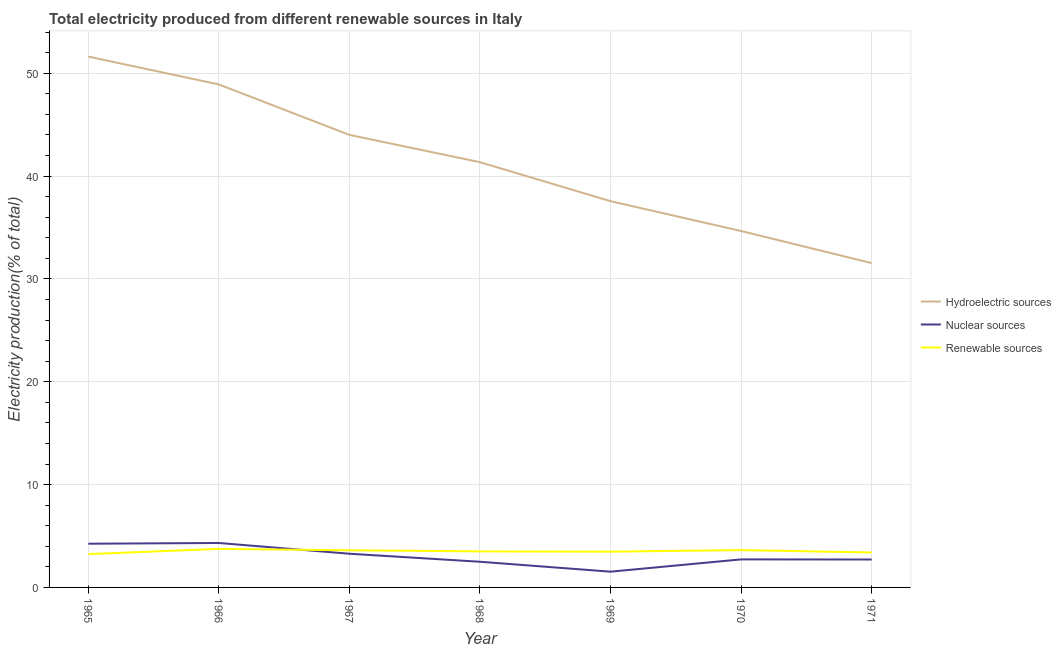How many different coloured lines are there?
Your answer should be very brief. 3. What is the percentage of electricity produced by nuclear sources in 1967?
Your answer should be very brief. 3.28. Across all years, what is the maximum percentage of electricity produced by hydroelectric sources?
Provide a short and direct response. 51.62. Across all years, what is the minimum percentage of electricity produced by nuclear sources?
Provide a succinct answer. 1.53. In which year was the percentage of electricity produced by renewable sources maximum?
Give a very brief answer. 1966. What is the total percentage of electricity produced by nuclear sources in the graph?
Your answer should be compact. 21.32. What is the difference between the percentage of electricity produced by renewable sources in 1965 and that in 1969?
Provide a short and direct response. -0.24. What is the difference between the percentage of electricity produced by hydroelectric sources in 1967 and the percentage of electricity produced by nuclear sources in 1966?
Give a very brief answer. 39.68. What is the average percentage of electricity produced by nuclear sources per year?
Make the answer very short. 3.05. In the year 1968, what is the difference between the percentage of electricity produced by renewable sources and percentage of electricity produced by nuclear sources?
Give a very brief answer. 1.01. In how many years, is the percentage of electricity produced by renewable sources greater than 4 %?
Offer a terse response. 0. What is the ratio of the percentage of electricity produced by nuclear sources in 1968 to that in 1971?
Your answer should be compact. 0.92. Is the percentage of electricity produced by nuclear sources in 1966 less than that in 1968?
Your response must be concise. No. Is the difference between the percentage of electricity produced by renewable sources in 1966 and 1971 greater than the difference between the percentage of electricity produced by hydroelectric sources in 1966 and 1971?
Give a very brief answer. No. What is the difference between the highest and the second highest percentage of electricity produced by nuclear sources?
Offer a terse response. 0.07. What is the difference between the highest and the lowest percentage of electricity produced by hydroelectric sources?
Offer a very short reply. 20.08. Is the sum of the percentage of electricity produced by renewable sources in 1966 and 1968 greater than the maximum percentage of electricity produced by hydroelectric sources across all years?
Your response must be concise. No. Is it the case that in every year, the sum of the percentage of electricity produced by hydroelectric sources and percentage of electricity produced by nuclear sources is greater than the percentage of electricity produced by renewable sources?
Your response must be concise. Yes. Does the percentage of electricity produced by nuclear sources monotonically increase over the years?
Your answer should be very brief. No. Is the percentage of electricity produced by nuclear sources strictly greater than the percentage of electricity produced by hydroelectric sources over the years?
Your answer should be very brief. No. How many lines are there?
Make the answer very short. 3. Does the graph contain any zero values?
Provide a short and direct response. No. How are the legend labels stacked?
Offer a very short reply. Vertical. What is the title of the graph?
Provide a succinct answer. Total electricity produced from different renewable sources in Italy. What is the label or title of the X-axis?
Ensure brevity in your answer.  Year. What is the label or title of the Y-axis?
Keep it short and to the point. Electricity production(% of total). What is the Electricity production(% of total) in Hydroelectric sources in 1965?
Your response must be concise. 51.62. What is the Electricity production(% of total) of Nuclear sources in 1965?
Your answer should be compact. 4.25. What is the Electricity production(% of total) in Renewable sources in 1965?
Offer a terse response. 3.24. What is the Electricity production(% of total) in Hydroelectric sources in 1966?
Ensure brevity in your answer.  48.91. What is the Electricity production(% of total) in Nuclear sources in 1966?
Provide a succinct answer. 4.32. What is the Electricity production(% of total) in Renewable sources in 1966?
Your response must be concise. 3.75. What is the Electricity production(% of total) of Hydroelectric sources in 1967?
Ensure brevity in your answer.  44. What is the Electricity production(% of total) in Nuclear sources in 1967?
Offer a very short reply. 3.28. What is the Electricity production(% of total) in Renewable sources in 1967?
Keep it short and to the point. 3.61. What is the Electricity production(% of total) of Hydroelectric sources in 1968?
Make the answer very short. 41.35. What is the Electricity production(% of total) in Nuclear sources in 1968?
Provide a succinct answer. 2.5. What is the Electricity production(% of total) of Renewable sources in 1968?
Keep it short and to the point. 3.5. What is the Electricity production(% of total) of Hydroelectric sources in 1969?
Your answer should be compact. 37.56. What is the Electricity production(% of total) in Nuclear sources in 1969?
Your answer should be very brief. 1.53. What is the Electricity production(% of total) in Renewable sources in 1969?
Make the answer very short. 3.48. What is the Electricity production(% of total) of Hydroelectric sources in 1970?
Your response must be concise. 34.66. What is the Electricity production(% of total) of Nuclear sources in 1970?
Ensure brevity in your answer.  2.73. What is the Electricity production(% of total) in Renewable sources in 1970?
Your response must be concise. 3.63. What is the Electricity production(% of total) of Hydroelectric sources in 1971?
Make the answer very short. 31.54. What is the Electricity production(% of total) of Nuclear sources in 1971?
Ensure brevity in your answer.  2.72. What is the Electricity production(% of total) in Renewable sources in 1971?
Provide a short and direct response. 3.4. Across all years, what is the maximum Electricity production(% of total) in Hydroelectric sources?
Make the answer very short. 51.62. Across all years, what is the maximum Electricity production(% of total) in Nuclear sources?
Give a very brief answer. 4.32. Across all years, what is the maximum Electricity production(% of total) of Renewable sources?
Make the answer very short. 3.75. Across all years, what is the minimum Electricity production(% of total) in Hydroelectric sources?
Your response must be concise. 31.54. Across all years, what is the minimum Electricity production(% of total) of Nuclear sources?
Your answer should be compact. 1.53. Across all years, what is the minimum Electricity production(% of total) of Renewable sources?
Provide a succinct answer. 3.24. What is the total Electricity production(% of total) in Hydroelectric sources in the graph?
Give a very brief answer. 289.63. What is the total Electricity production(% of total) in Nuclear sources in the graph?
Keep it short and to the point. 21.32. What is the total Electricity production(% of total) of Renewable sources in the graph?
Offer a terse response. 24.61. What is the difference between the Electricity production(% of total) in Hydroelectric sources in 1965 and that in 1966?
Your response must be concise. 2.71. What is the difference between the Electricity production(% of total) of Nuclear sources in 1965 and that in 1966?
Provide a succinct answer. -0.07. What is the difference between the Electricity production(% of total) of Renewable sources in 1965 and that in 1966?
Offer a terse response. -0.51. What is the difference between the Electricity production(% of total) of Hydroelectric sources in 1965 and that in 1967?
Your answer should be compact. 7.62. What is the difference between the Electricity production(% of total) in Nuclear sources in 1965 and that in 1967?
Provide a short and direct response. 0.97. What is the difference between the Electricity production(% of total) in Renewable sources in 1965 and that in 1967?
Your response must be concise. -0.37. What is the difference between the Electricity production(% of total) of Hydroelectric sources in 1965 and that in 1968?
Your answer should be very brief. 10.27. What is the difference between the Electricity production(% of total) in Nuclear sources in 1965 and that in 1968?
Give a very brief answer. 1.75. What is the difference between the Electricity production(% of total) of Renewable sources in 1965 and that in 1968?
Your response must be concise. -0.26. What is the difference between the Electricity production(% of total) in Hydroelectric sources in 1965 and that in 1969?
Make the answer very short. 14.06. What is the difference between the Electricity production(% of total) in Nuclear sources in 1965 and that in 1969?
Provide a short and direct response. 2.72. What is the difference between the Electricity production(% of total) in Renewable sources in 1965 and that in 1969?
Give a very brief answer. -0.24. What is the difference between the Electricity production(% of total) in Hydroelectric sources in 1965 and that in 1970?
Your answer should be very brief. 16.96. What is the difference between the Electricity production(% of total) of Nuclear sources in 1965 and that in 1970?
Offer a terse response. 1.52. What is the difference between the Electricity production(% of total) in Renewable sources in 1965 and that in 1970?
Offer a very short reply. -0.39. What is the difference between the Electricity production(% of total) in Hydroelectric sources in 1965 and that in 1971?
Provide a short and direct response. 20.08. What is the difference between the Electricity production(% of total) of Nuclear sources in 1965 and that in 1971?
Provide a succinct answer. 1.53. What is the difference between the Electricity production(% of total) of Renewable sources in 1965 and that in 1971?
Your response must be concise. -0.16. What is the difference between the Electricity production(% of total) of Hydroelectric sources in 1966 and that in 1967?
Your answer should be compact. 4.9. What is the difference between the Electricity production(% of total) in Nuclear sources in 1966 and that in 1967?
Your answer should be compact. 1.05. What is the difference between the Electricity production(% of total) in Renewable sources in 1966 and that in 1967?
Provide a succinct answer. 0.14. What is the difference between the Electricity production(% of total) in Hydroelectric sources in 1966 and that in 1968?
Provide a short and direct response. 7.56. What is the difference between the Electricity production(% of total) in Nuclear sources in 1966 and that in 1968?
Make the answer very short. 1.83. What is the difference between the Electricity production(% of total) of Renewable sources in 1966 and that in 1968?
Ensure brevity in your answer.  0.24. What is the difference between the Electricity production(% of total) of Hydroelectric sources in 1966 and that in 1969?
Provide a short and direct response. 11.35. What is the difference between the Electricity production(% of total) in Nuclear sources in 1966 and that in 1969?
Your response must be concise. 2.79. What is the difference between the Electricity production(% of total) of Renewable sources in 1966 and that in 1969?
Offer a very short reply. 0.27. What is the difference between the Electricity production(% of total) of Hydroelectric sources in 1966 and that in 1970?
Provide a succinct answer. 14.25. What is the difference between the Electricity production(% of total) in Nuclear sources in 1966 and that in 1970?
Ensure brevity in your answer.  1.6. What is the difference between the Electricity production(% of total) of Renewable sources in 1966 and that in 1970?
Offer a very short reply. 0.12. What is the difference between the Electricity production(% of total) of Hydroelectric sources in 1966 and that in 1971?
Your answer should be compact. 17.37. What is the difference between the Electricity production(% of total) in Nuclear sources in 1966 and that in 1971?
Ensure brevity in your answer.  1.61. What is the difference between the Electricity production(% of total) of Renewable sources in 1966 and that in 1971?
Your response must be concise. 0.35. What is the difference between the Electricity production(% of total) of Hydroelectric sources in 1967 and that in 1968?
Provide a succinct answer. 2.65. What is the difference between the Electricity production(% of total) in Nuclear sources in 1967 and that in 1968?
Make the answer very short. 0.78. What is the difference between the Electricity production(% of total) in Renewable sources in 1967 and that in 1968?
Keep it short and to the point. 0.11. What is the difference between the Electricity production(% of total) in Hydroelectric sources in 1967 and that in 1969?
Make the answer very short. 6.45. What is the difference between the Electricity production(% of total) in Nuclear sources in 1967 and that in 1969?
Your response must be concise. 1.74. What is the difference between the Electricity production(% of total) in Renewable sources in 1967 and that in 1969?
Your answer should be very brief. 0.13. What is the difference between the Electricity production(% of total) of Hydroelectric sources in 1967 and that in 1970?
Offer a terse response. 9.35. What is the difference between the Electricity production(% of total) of Nuclear sources in 1967 and that in 1970?
Keep it short and to the point. 0.55. What is the difference between the Electricity production(% of total) of Renewable sources in 1967 and that in 1970?
Ensure brevity in your answer.  -0.02. What is the difference between the Electricity production(% of total) of Hydroelectric sources in 1967 and that in 1971?
Provide a succinct answer. 12.47. What is the difference between the Electricity production(% of total) of Nuclear sources in 1967 and that in 1971?
Keep it short and to the point. 0.56. What is the difference between the Electricity production(% of total) in Renewable sources in 1967 and that in 1971?
Provide a short and direct response. 0.21. What is the difference between the Electricity production(% of total) of Hydroelectric sources in 1968 and that in 1969?
Offer a terse response. 3.79. What is the difference between the Electricity production(% of total) of Nuclear sources in 1968 and that in 1969?
Make the answer very short. 0.96. What is the difference between the Electricity production(% of total) of Renewable sources in 1968 and that in 1969?
Offer a terse response. 0.03. What is the difference between the Electricity production(% of total) in Hydroelectric sources in 1968 and that in 1970?
Ensure brevity in your answer.  6.69. What is the difference between the Electricity production(% of total) in Nuclear sources in 1968 and that in 1970?
Offer a very short reply. -0.23. What is the difference between the Electricity production(% of total) of Renewable sources in 1968 and that in 1970?
Your response must be concise. -0.12. What is the difference between the Electricity production(% of total) in Hydroelectric sources in 1968 and that in 1971?
Provide a short and direct response. 9.81. What is the difference between the Electricity production(% of total) in Nuclear sources in 1968 and that in 1971?
Offer a terse response. -0.22. What is the difference between the Electricity production(% of total) of Renewable sources in 1968 and that in 1971?
Your answer should be compact. 0.11. What is the difference between the Electricity production(% of total) in Nuclear sources in 1969 and that in 1970?
Ensure brevity in your answer.  -1.19. What is the difference between the Electricity production(% of total) of Renewable sources in 1969 and that in 1970?
Keep it short and to the point. -0.15. What is the difference between the Electricity production(% of total) of Hydroelectric sources in 1969 and that in 1971?
Provide a succinct answer. 6.02. What is the difference between the Electricity production(% of total) in Nuclear sources in 1969 and that in 1971?
Offer a very short reply. -1.18. What is the difference between the Electricity production(% of total) of Renewable sources in 1969 and that in 1971?
Offer a terse response. 0.08. What is the difference between the Electricity production(% of total) in Hydroelectric sources in 1970 and that in 1971?
Provide a succinct answer. 3.12. What is the difference between the Electricity production(% of total) of Nuclear sources in 1970 and that in 1971?
Keep it short and to the point. 0.01. What is the difference between the Electricity production(% of total) of Renewable sources in 1970 and that in 1971?
Provide a succinct answer. 0.23. What is the difference between the Electricity production(% of total) of Hydroelectric sources in 1965 and the Electricity production(% of total) of Nuclear sources in 1966?
Give a very brief answer. 47.3. What is the difference between the Electricity production(% of total) in Hydroelectric sources in 1965 and the Electricity production(% of total) in Renewable sources in 1966?
Your answer should be very brief. 47.87. What is the difference between the Electricity production(% of total) in Nuclear sources in 1965 and the Electricity production(% of total) in Renewable sources in 1966?
Offer a very short reply. 0.5. What is the difference between the Electricity production(% of total) of Hydroelectric sources in 1965 and the Electricity production(% of total) of Nuclear sources in 1967?
Provide a short and direct response. 48.34. What is the difference between the Electricity production(% of total) of Hydroelectric sources in 1965 and the Electricity production(% of total) of Renewable sources in 1967?
Keep it short and to the point. 48.01. What is the difference between the Electricity production(% of total) in Nuclear sources in 1965 and the Electricity production(% of total) in Renewable sources in 1967?
Make the answer very short. 0.64. What is the difference between the Electricity production(% of total) in Hydroelectric sources in 1965 and the Electricity production(% of total) in Nuclear sources in 1968?
Give a very brief answer. 49.12. What is the difference between the Electricity production(% of total) in Hydroelectric sources in 1965 and the Electricity production(% of total) in Renewable sources in 1968?
Offer a terse response. 48.11. What is the difference between the Electricity production(% of total) in Nuclear sources in 1965 and the Electricity production(% of total) in Renewable sources in 1968?
Give a very brief answer. 0.75. What is the difference between the Electricity production(% of total) of Hydroelectric sources in 1965 and the Electricity production(% of total) of Nuclear sources in 1969?
Make the answer very short. 50.09. What is the difference between the Electricity production(% of total) of Hydroelectric sources in 1965 and the Electricity production(% of total) of Renewable sources in 1969?
Your response must be concise. 48.14. What is the difference between the Electricity production(% of total) of Nuclear sources in 1965 and the Electricity production(% of total) of Renewable sources in 1969?
Keep it short and to the point. 0.77. What is the difference between the Electricity production(% of total) in Hydroelectric sources in 1965 and the Electricity production(% of total) in Nuclear sources in 1970?
Offer a terse response. 48.89. What is the difference between the Electricity production(% of total) of Hydroelectric sources in 1965 and the Electricity production(% of total) of Renewable sources in 1970?
Keep it short and to the point. 47.99. What is the difference between the Electricity production(% of total) in Nuclear sources in 1965 and the Electricity production(% of total) in Renewable sources in 1970?
Provide a succinct answer. 0.62. What is the difference between the Electricity production(% of total) in Hydroelectric sources in 1965 and the Electricity production(% of total) in Nuclear sources in 1971?
Keep it short and to the point. 48.9. What is the difference between the Electricity production(% of total) of Hydroelectric sources in 1965 and the Electricity production(% of total) of Renewable sources in 1971?
Keep it short and to the point. 48.22. What is the difference between the Electricity production(% of total) in Nuclear sources in 1965 and the Electricity production(% of total) in Renewable sources in 1971?
Ensure brevity in your answer.  0.85. What is the difference between the Electricity production(% of total) of Hydroelectric sources in 1966 and the Electricity production(% of total) of Nuclear sources in 1967?
Provide a succinct answer. 45.63. What is the difference between the Electricity production(% of total) of Hydroelectric sources in 1966 and the Electricity production(% of total) of Renewable sources in 1967?
Make the answer very short. 45.3. What is the difference between the Electricity production(% of total) of Nuclear sources in 1966 and the Electricity production(% of total) of Renewable sources in 1967?
Offer a terse response. 0.71. What is the difference between the Electricity production(% of total) of Hydroelectric sources in 1966 and the Electricity production(% of total) of Nuclear sources in 1968?
Keep it short and to the point. 46.41. What is the difference between the Electricity production(% of total) of Hydroelectric sources in 1966 and the Electricity production(% of total) of Renewable sources in 1968?
Your answer should be very brief. 45.4. What is the difference between the Electricity production(% of total) in Nuclear sources in 1966 and the Electricity production(% of total) in Renewable sources in 1968?
Ensure brevity in your answer.  0.82. What is the difference between the Electricity production(% of total) in Hydroelectric sources in 1966 and the Electricity production(% of total) in Nuclear sources in 1969?
Give a very brief answer. 47.38. What is the difference between the Electricity production(% of total) in Hydroelectric sources in 1966 and the Electricity production(% of total) in Renewable sources in 1969?
Give a very brief answer. 45.43. What is the difference between the Electricity production(% of total) of Nuclear sources in 1966 and the Electricity production(% of total) of Renewable sources in 1969?
Your response must be concise. 0.84. What is the difference between the Electricity production(% of total) of Hydroelectric sources in 1966 and the Electricity production(% of total) of Nuclear sources in 1970?
Provide a succinct answer. 46.18. What is the difference between the Electricity production(% of total) of Hydroelectric sources in 1966 and the Electricity production(% of total) of Renewable sources in 1970?
Provide a short and direct response. 45.28. What is the difference between the Electricity production(% of total) of Nuclear sources in 1966 and the Electricity production(% of total) of Renewable sources in 1970?
Your response must be concise. 0.69. What is the difference between the Electricity production(% of total) of Hydroelectric sources in 1966 and the Electricity production(% of total) of Nuclear sources in 1971?
Your answer should be compact. 46.19. What is the difference between the Electricity production(% of total) in Hydroelectric sources in 1966 and the Electricity production(% of total) in Renewable sources in 1971?
Your answer should be very brief. 45.51. What is the difference between the Electricity production(% of total) in Nuclear sources in 1966 and the Electricity production(% of total) in Renewable sources in 1971?
Your response must be concise. 0.92. What is the difference between the Electricity production(% of total) in Hydroelectric sources in 1967 and the Electricity production(% of total) in Nuclear sources in 1968?
Offer a terse response. 41.51. What is the difference between the Electricity production(% of total) of Hydroelectric sources in 1967 and the Electricity production(% of total) of Renewable sources in 1968?
Ensure brevity in your answer.  40.5. What is the difference between the Electricity production(% of total) in Nuclear sources in 1967 and the Electricity production(% of total) in Renewable sources in 1968?
Offer a very short reply. -0.23. What is the difference between the Electricity production(% of total) of Hydroelectric sources in 1967 and the Electricity production(% of total) of Nuclear sources in 1969?
Make the answer very short. 42.47. What is the difference between the Electricity production(% of total) of Hydroelectric sources in 1967 and the Electricity production(% of total) of Renewable sources in 1969?
Offer a very short reply. 40.53. What is the difference between the Electricity production(% of total) of Nuclear sources in 1967 and the Electricity production(% of total) of Renewable sources in 1969?
Offer a terse response. -0.2. What is the difference between the Electricity production(% of total) in Hydroelectric sources in 1967 and the Electricity production(% of total) in Nuclear sources in 1970?
Your answer should be very brief. 41.28. What is the difference between the Electricity production(% of total) in Hydroelectric sources in 1967 and the Electricity production(% of total) in Renewable sources in 1970?
Make the answer very short. 40.37. What is the difference between the Electricity production(% of total) of Nuclear sources in 1967 and the Electricity production(% of total) of Renewable sources in 1970?
Keep it short and to the point. -0.35. What is the difference between the Electricity production(% of total) in Hydroelectric sources in 1967 and the Electricity production(% of total) in Nuclear sources in 1971?
Offer a very short reply. 41.29. What is the difference between the Electricity production(% of total) in Hydroelectric sources in 1967 and the Electricity production(% of total) in Renewable sources in 1971?
Provide a succinct answer. 40.61. What is the difference between the Electricity production(% of total) of Nuclear sources in 1967 and the Electricity production(% of total) of Renewable sources in 1971?
Ensure brevity in your answer.  -0.12. What is the difference between the Electricity production(% of total) of Hydroelectric sources in 1968 and the Electricity production(% of total) of Nuclear sources in 1969?
Your answer should be very brief. 39.82. What is the difference between the Electricity production(% of total) of Hydroelectric sources in 1968 and the Electricity production(% of total) of Renewable sources in 1969?
Keep it short and to the point. 37.87. What is the difference between the Electricity production(% of total) in Nuclear sources in 1968 and the Electricity production(% of total) in Renewable sources in 1969?
Offer a terse response. -0.98. What is the difference between the Electricity production(% of total) in Hydroelectric sources in 1968 and the Electricity production(% of total) in Nuclear sources in 1970?
Make the answer very short. 38.62. What is the difference between the Electricity production(% of total) of Hydroelectric sources in 1968 and the Electricity production(% of total) of Renewable sources in 1970?
Ensure brevity in your answer.  37.72. What is the difference between the Electricity production(% of total) in Nuclear sources in 1968 and the Electricity production(% of total) in Renewable sources in 1970?
Provide a short and direct response. -1.13. What is the difference between the Electricity production(% of total) of Hydroelectric sources in 1968 and the Electricity production(% of total) of Nuclear sources in 1971?
Provide a succinct answer. 38.63. What is the difference between the Electricity production(% of total) of Hydroelectric sources in 1968 and the Electricity production(% of total) of Renewable sources in 1971?
Offer a very short reply. 37.95. What is the difference between the Electricity production(% of total) of Nuclear sources in 1968 and the Electricity production(% of total) of Renewable sources in 1971?
Your answer should be compact. -0.9. What is the difference between the Electricity production(% of total) in Hydroelectric sources in 1969 and the Electricity production(% of total) in Nuclear sources in 1970?
Your response must be concise. 34.83. What is the difference between the Electricity production(% of total) in Hydroelectric sources in 1969 and the Electricity production(% of total) in Renewable sources in 1970?
Give a very brief answer. 33.93. What is the difference between the Electricity production(% of total) of Nuclear sources in 1969 and the Electricity production(% of total) of Renewable sources in 1970?
Ensure brevity in your answer.  -2.1. What is the difference between the Electricity production(% of total) of Hydroelectric sources in 1969 and the Electricity production(% of total) of Nuclear sources in 1971?
Ensure brevity in your answer.  34.84. What is the difference between the Electricity production(% of total) in Hydroelectric sources in 1969 and the Electricity production(% of total) in Renewable sources in 1971?
Provide a short and direct response. 34.16. What is the difference between the Electricity production(% of total) of Nuclear sources in 1969 and the Electricity production(% of total) of Renewable sources in 1971?
Give a very brief answer. -1.86. What is the difference between the Electricity production(% of total) in Hydroelectric sources in 1970 and the Electricity production(% of total) in Nuclear sources in 1971?
Offer a very short reply. 31.94. What is the difference between the Electricity production(% of total) in Hydroelectric sources in 1970 and the Electricity production(% of total) in Renewable sources in 1971?
Ensure brevity in your answer.  31.26. What is the difference between the Electricity production(% of total) in Nuclear sources in 1970 and the Electricity production(% of total) in Renewable sources in 1971?
Ensure brevity in your answer.  -0.67. What is the average Electricity production(% of total) in Hydroelectric sources per year?
Keep it short and to the point. 41.38. What is the average Electricity production(% of total) of Nuclear sources per year?
Make the answer very short. 3.05. What is the average Electricity production(% of total) of Renewable sources per year?
Offer a terse response. 3.52. In the year 1965, what is the difference between the Electricity production(% of total) in Hydroelectric sources and Electricity production(% of total) in Nuclear sources?
Offer a very short reply. 47.37. In the year 1965, what is the difference between the Electricity production(% of total) of Hydroelectric sources and Electricity production(% of total) of Renewable sources?
Offer a very short reply. 48.38. In the year 1965, what is the difference between the Electricity production(% of total) in Nuclear sources and Electricity production(% of total) in Renewable sources?
Offer a very short reply. 1.01. In the year 1966, what is the difference between the Electricity production(% of total) of Hydroelectric sources and Electricity production(% of total) of Nuclear sources?
Keep it short and to the point. 44.59. In the year 1966, what is the difference between the Electricity production(% of total) in Hydroelectric sources and Electricity production(% of total) in Renewable sources?
Give a very brief answer. 45.16. In the year 1966, what is the difference between the Electricity production(% of total) in Nuclear sources and Electricity production(% of total) in Renewable sources?
Give a very brief answer. 0.57. In the year 1967, what is the difference between the Electricity production(% of total) in Hydroelectric sources and Electricity production(% of total) in Nuclear sources?
Ensure brevity in your answer.  40.73. In the year 1967, what is the difference between the Electricity production(% of total) of Hydroelectric sources and Electricity production(% of total) of Renewable sources?
Your answer should be very brief. 40.39. In the year 1967, what is the difference between the Electricity production(% of total) of Nuclear sources and Electricity production(% of total) of Renewable sources?
Keep it short and to the point. -0.34. In the year 1968, what is the difference between the Electricity production(% of total) in Hydroelectric sources and Electricity production(% of total) in Nuclear sources?
Your response must be concise. 38.85. In the year 1968, what is the difference between the Electricity production(% of total) in Hydroelectric sources and Electricity production(% of total) in Renewable sources?
Offer a very short reply. 37.84. In the year 1968, what is the difference between the Electricity production(% of total) of Nuclear sources and Electricity production(% of total) of Renewable sources?
Give a very brief answer. -1.01. In the year 1969, what is the difference between the Electricity production(% of total) of Hydroelectric sources and Electricity production(% of total) of Nuclear sources?
Offer a terse response. 36.02. In the year 1969, what is the difference between the Electricity production(% of total) in Hydroelectric sources and Electricity production(% of total) in Renewable sources?
Offer a terse response. 34.08. In the year 1969, what is the difference between the Electricity production(% of total) of Nuclear sources and Electricity production(% of total) of Renewable sources?
Keep it short and to the point. -1.95. In the year 1970, what is the difference between the Electricity production(% of total) in Hydroelectric sources and Electricity production(% of total) in Nuclear sources?
Make the answer very short. 31.93. In the year 1970, what is the difference between the Electricity production(% of total) of Hydroelectric sources and Electricity production(% of total) of Renewable sources?
Your answer should be compact. 31.03. In the year 1970, what is the difference between the Electricity production(% of total) of Nuclear sources and Electricity production(% of total) of Renewable sources?
Your answer should be very brief. -0.9. In the year 1971, what is the difference between the Electricity production(% of total) in Hydroelectric sources and Electricity production(% of total) in Nuclear sources?
Provide a succinct answer. 28.82. In the year 1971, what is the difference between the Electricity production(% of total) of Hydroelectric sources and Electricity production(% of total) of Renewable sources?
Give a very brief answer. 28.14. In the year 1971, what is the difference between the Electricity production(% of total) of Nuclear sources and Electricity production(% of total) of Renewable sources?
Make the answer very short. -0.68. What is the ratio of the Electricity production(% of total) in Hydroelectric sources in 1965 to that in 1966?
Your response must be concise. 1.06. What is the ratio of the Electricity production(% of total) in Nuclear sources in 1965 to that in 1966?
Ensure brevity in your answer.  0.98. What is the ratio of the Electricity production(% of total) of Renewable sources in 1965 to that in 1966?
Provide a succinct answer. 0.86. What is the ratio of the Electricity production(% of total) in Hydroelectric sources in 1965 to that in 1967?
Your answer should be very brief. 1.17. What is the ratio of the Electricity production(% of total) of Nuclear sources in 1965 to that in 1967?
Provide a succinct answer. 1.3. What is the ratio of the Electricity production(% of total) in Renewable sources in 1965 to that in 1967?
Your answer should be compact. 0.9. What is the ratio of the Electricity production(% of total) of Hydroelectric sources in 1965 to that in 1968?
Your response must be concise. 1.25. What is the ratio of the Electricity production(% of total) of Nuclear sources in 1965 to that in 1968?
Keep it short and to the point. 1.7. What is the ratio of the Electricity production(% of total) of Renewable sources in 1965 to that in 1968?
Your answer should be compact. 0.92. What is the ratio of the Electricity production(% of total) of Hydroelectric sources in 1965 to that in 1969?
Provide a short and direct response. 1.37. What is the ratio of the Electricity production(% of total) of Nuclear sources in 1965 to that in 1969?
Keep it short and to the point. 2.77. What is the ratio of the Electricity production(% of total) of Renewable sources in 1965 to that in 1969?
Ensure brevity in your answer.  0.93. What is the ratio of the Electricity production(% of total) in Hydroelectric sources in 1965 to that in 1970?
Your response must be concise. 1.49. What is the ratio of the Electricity production(% of total) of Nuclear sources in 1965 to that in 1970?
Ensure brevity in your answer.  1.56. What is the ratio of the Electricity production(% of total) of Renewable sources in 1965 to that in 1970?
Your answer should be compact. 0.89. What is the ratio of the Electricity production(% of total) of Hydroelectric sources in 1965 to that in 1971?
Make the answer very short. 1.64. What is the ratio of the Electricity production(% of total) of Nuclear sources in 1965 to that in 1971?
Provide a succinct answer. 1.56. What is the ratio of the Electricity production(% of total) in Renewable sources in 1965 to that in 1971?
Offer a terse response. 0.95. What is the ratio of the Electricity production(% of total) of Hydroelectric sources in 1966 to that in 1967?
Your answer should be very brief. 1.11. What is the ratio of the Electricity production(% of total) of Nuclear sources in 1966 to that in 1967?
Make the answer very short. 1.32. What is the ratio of the Electricity production(% of total) in Renewable sources in 1966 to that in 1967?
Offer a very short reply. 1.04. What is the ratio of the Electricity production(% of total) in Hydroelectric sources in 1966 to that in 1968?
Make the answer very short. 1.18. What is the ratio of the Electricity production(% of total) of Nuclear sources in 1966 to that in 1968?
Offer a terse response. 1.73. What is the ratio of the Electricity production(% of total) of Renewable sources in 1966 to that in 1968?
Your answer should be very brief. 1.07. What is the ratio of the Electricity production(% of total) of Hydroelectric sources in 1966 to that in 1969?
Ensure brevity in your answer.  1.3. What is the ratio of the Electricity production(% of total) in Nuclear sources in 1966 to that in 1969?
Provide a short and direct response. 2.82. What is the ratio of the Electricity production(% of total) in Renewable sources in 1966 to that in 1969?
Give a very brief answer. 1.08. What is the ratio of the Electricity production(% of total) in Hydroelectric sources in 1966 to that in 1970?
Give a very brief answer. 1.41. What is the ratio of the Electricity production(% of total) of Nuclear sources in 1966 to that in 1970?
Your answer should be compact. 1.59. What is the ratio of the Electricity production(% of total) in Renewable sources in 1966 to that in 1970?
Keep it short and to the point. 1.03. What is the ratio of the Electricity production(% of total) of Hydroelectric sources in 1966 to that in 1971?
Offer a terse response. 1.55. What is the ratio of the Electricity production(% of total) of Nuclear sources in 1966 to that in 1971?
Offer a very short reply. 1.59. What is the ratio of the Electricity production(% of total) of Renewable sources in 1966 to that in 1971?
Provide a short and direct response. 1.1. What is the ratio of the Electricity production(% of total) of Hydroelectric sources in 1967 to that in 1968?
Your answer should be very brief. 1.06. What is the ratio of the Electricity production(% of total) of Nuclear sources in 1967 to that in 1968?
Offer a terse response. 1.31. What is the ratio of the Electricity production(% of total) in Renewable sources in 1967 to that in 1968?
Make the answer very short. 1.03. What is the ratio of the Electricity production(% of total) in Hydroelectric sources in 1967 to that in 1969?
Offer a very short reply. 1.17. What is the ratio of the Electricity production(% of total) in Nuclear sources in 1967 to that in 1969?
Provide a short and direct response. 2.14. What is the ratio of the Electricity production(% of total) in Renewable sources in 1967 to that in 1969?
Offer a terse response. 1.04. What is the ratio of the Electricity production(% of total) in Hydroelectric sources in 1967 to that in 1970?
Ensure brevity in your answer.  1.27. What is the ratio of the Electricity production(% of total) in Nuclear sources in 1967 to that in 1970?
Provide a succinct answer. 1.2. What is the ratio of the Electricity production(% of total) of Hydroelectric sources in 1967 to that in 1971?
Your answer should be compact. 1.4. What is the ratio of the Electricity production(% of total) in Nuclear sources in 1967 to that in 1971?
Give a very brief answer. 1.21. What is the ratio of the Electricity production(% of total) of Renewable sources in 1967 to that in 1971?
Offer a terse response. 1.06. What is the ratio of the Electricity production(% of total) in Hydroelectric sources in 1968 to that in 1969?
Offer a terse response. 1.1. What is the ratio of the Electricity production(% of total) in Nuclear sources in 1968 to that in 1969?
Give a very brief answer. 1.63. What is the ratio of the Electricity production(% of total) in Renewable sources in 1968 to that in 1969?
Provide a succinct answer. 1.01. What is the ratio of the Electricity production(% of total) in Hydroelectric sources in 1968 to that in 1970?
Your answer should be compact. 1.19. What is the ratio of the Electricity production(% of total) of Nuclear sources in 1968 to that in 1970?
Keep it short and to the point. 0.92. What is the ratio of the Electricity production(% of total) of Renewable sources in 1968 to that in 1970?
Your answer should be compact. 0.97. What is the ratio of the Electricity production(% of total) of Hydroelectric sources in 1968 to that in 1971?
Your answer should be very brief. 1.31. What is the ratio of the Electricity production(% of total) of Nuclear sources in 1968 to that in 1971?
Ensure brevity in your answer.  0.92. What is the ratio of the Electricity production(% of total) of Renewable sources in 1968 to that in 1971?
Keep it short and to the point. 1.03. What is the ratio of the Electricity production(% of total) of Hydroelectric sources in 1969 to that in 1970?
Provide a short and direct response. 1.08. What is the ratio of the Electricity production(% of total) in Nuclear sources in 1969 to that in 1970?
Offer a terse response. 0.56. What is the ratio of the Electricity production(% of total) of Renewable sources in 1969 to that in 1970?
Make the answer very short. 0.96. What is the ratio of the Electricity production(% of total) in Hydroelectric sources in 1969 to that in 1971?
Your answer should be compact. 1.19. What is the ratio of the Electricity production(% of total) in Nuclear sources in 1969 to that in 1971?
Keep it short and to the point. 0.56. What is the ratio of the Electricity production(% of total) of Renewable sources in 1969 to that in 1971?
Your answer should be compact. 1.02. What is the ratio of the Electricity production(% of total) in Hydroelectric sources in 1970 to that in 1971?
Keep it short and to the point. 1.1. What is the ratio of the Electricity production(% of total) in Renewable sources in 1970 to that in 1971?
Provide a short and direct response. 1.07. What is the difference between the highest and the second highest Electricity production(% of total) of Hydroelectric sources?
Offer a terse response. 2.71. What is the difference between the highest and the second highest Electricity production(% of total) in Nuclear sources?
Provide a succinct answer. 0.07. What is the difference between the highest and the second highest Electricity production(% of total) of Renewable sources?
Offer a terse response. 0.12. What is the difference between the highest and the lowest Electricity production(% of total) of Hydroelectric sources?
Ensure brevity in your answer.  20.08. What is the difference between the highest and the lowest Electricity production(% of total) in Nuclear sources?
Keep it short and to the point. 2.79. What is the difference between the highest and the lowest Electricity production(% of total) of Renewable sources?
Offer a terse response. 0.51. 